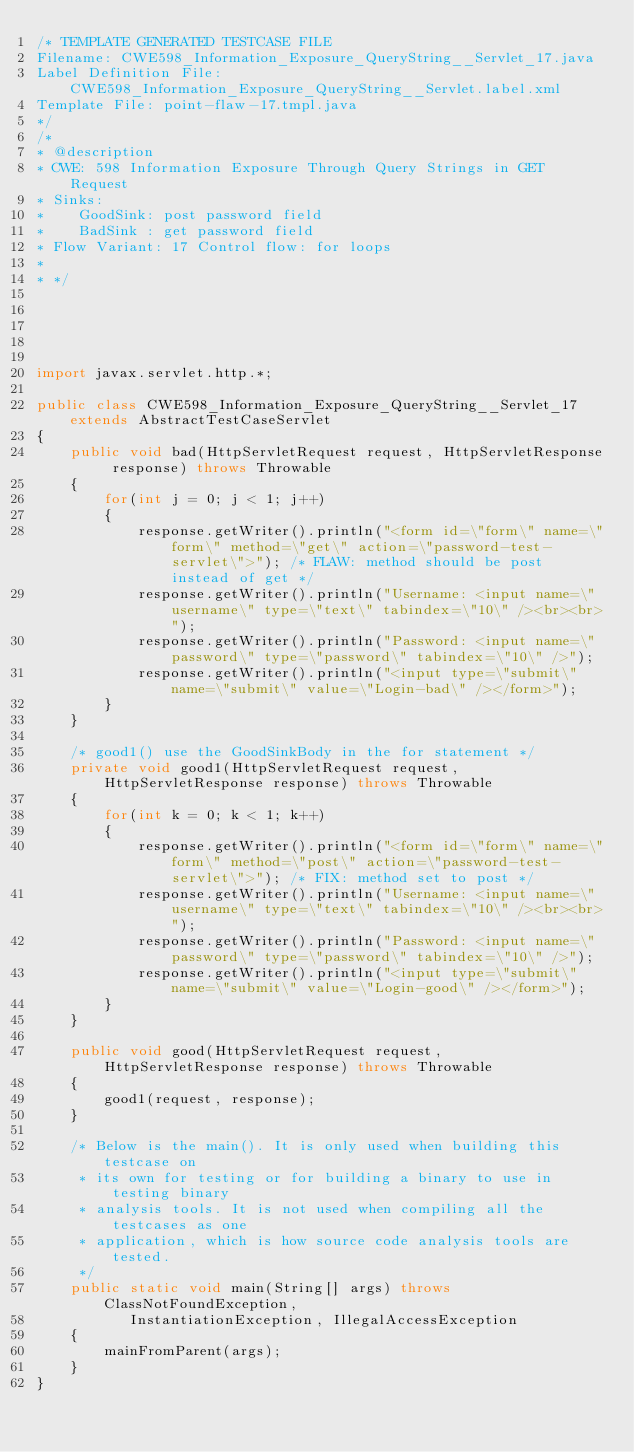<code> <loc_0><loc_0><loc_500><loc_500><_Java_>/* TEMPLATE GENERATED TESTCASE FILE
Filename: CWE598_Information_Exposure_QueryString__Servlet_17.java
Label Definition File: CWE598_Information_Exposure_QueryString__Servlet.label.xml
Template File: point-flaw-17.tmpl.java
*/
/*
* @description
* CWE: 598 Information Exposure Through Query Strings in GET Request
* Sinks:
*    GoodSink: post password field
*    BadSink : get password field
* Flow Variant: 17 Control flow: for loops
*
* */





import javax.servlet.http.*;

public class CWE598_Information_Exposure_QueryString__Servlet_17 extends AbstractTestCaseServlet
{
    public void bad(HttpServletRequest request, HttpServletResponse response) throws Throwable
    {
        for(int j = 0; j < 1; j++)
        {
            response.getWriter().println("<form id=\"form\" name=\"form\" method=\"get\" action=\"password-test-servlet\">"); /* FLAW: method should be post instead of get */
            response.getWriter().println("Username: <input name=\"username\" type=\"text\" tabindex=\"10\" /><br><br>");
            response.getWriter().println("Password: <input name=\"password\" type=\"password\" tabindex=\"10\" />");
            response.getWriter().println("<input type=\"submit\" name=\"submit\" value=\"Login-bad\" /></form>");
        }
    }

    /* good1() use the GoodSinkBody in the for statement */
    private void good1(HttpServletRequest request, HttpServletResponse response) throws Throwable
    {
        for(int k = 0; k < 1; k++)
        {
            response.getWriter().println("<form id=\"form\" name=\"form\" method=\"post\" action=\"password-test-servlet\">"); /* FIX: method set to post */
            response.getWriter().println("Username: <input name=\"username\" type=\"text\" tabindex=\"10\" /><br><br>");
            response.getWriter().println("Password: <input name=\"password\" type=\"password\" tabindex=\"10\" />");
            response.getWriter().println("<input type=\"submit\" name=\"submit\" value=\"Login-good\" /></form>");
        }
    }

    public void good(HttpServletRequest request, HttpServletResponse response) throws Throwable
    {
        good1(request, response);
    }

    /* Below is the main(). It is only used when building this testcase on
     * its own for testing or for building a binary to use in testing binary
     * analysis tools. It is not used when compiling all the testcases as one
     * application, which is how source code analysis tools are tested.
     */
    public static void main(String[] args) throws ClassNotFoundException,
           InstantiationException, IllegalAccessException
    {
        mainFromParent(args);
    }
}
</code> 